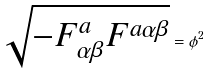<formula> <loc_0><loc_0><loc_500><loc_500>\sqrt { - F _ { \alpha \beta } ^ { a } F ^ { a \alpha \beta } } = \phi ^ { 2 }</formula> 